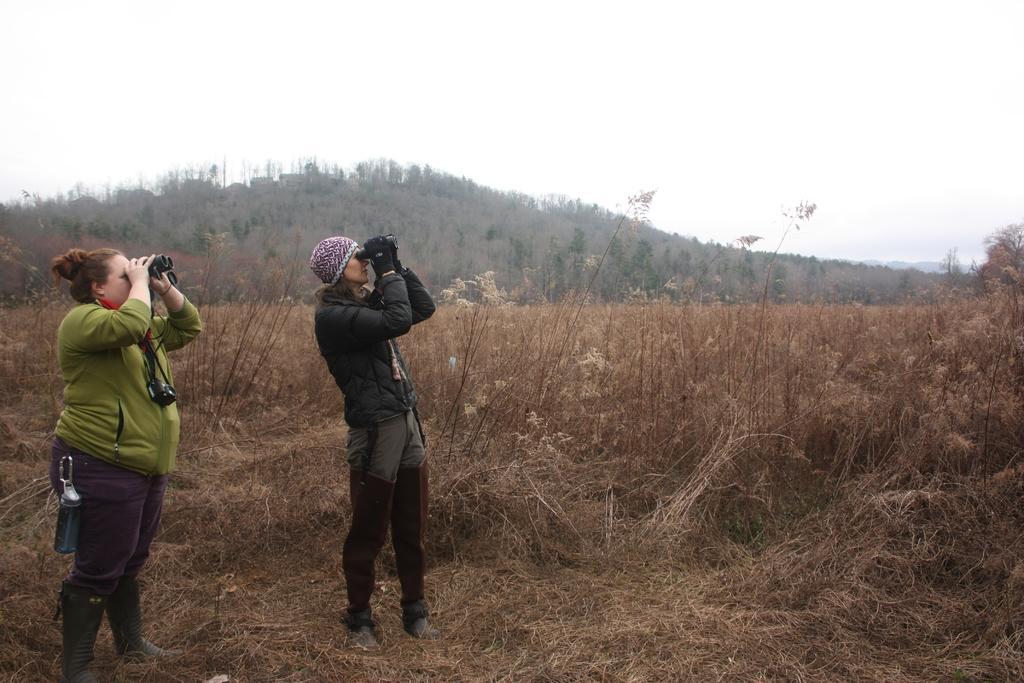Can you describe this image briefly? In this picture we can see two women are standing and holding pairs of binoculars, a woman on the left side is carrying a bottle, at the bottom there are some plants, we can see trees in the background, there is the sky at the top of the picture. 